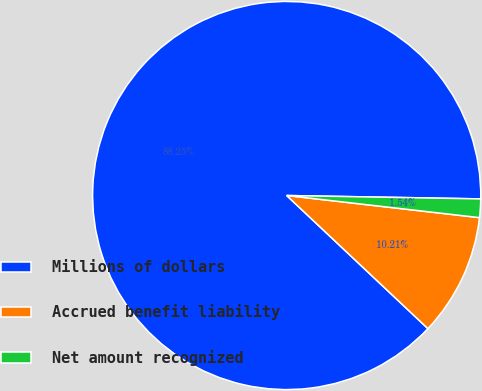Convert chart to OTSL. <chart><loc_0><loc_0><loc_500><loc_500><pie_chart><fcel>Millions of dollars<fcel>Accrued benefit liability<fcel>Net amount recognized<nl><fcel>88.25%<fcel>10.21%<fcel>1.54%<nl></chart> 